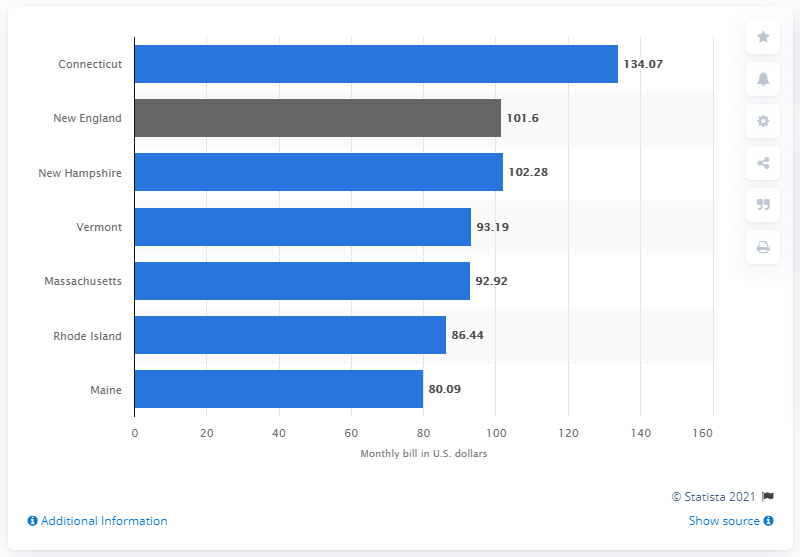List a handful of essential elements in this visual. In 2011, the average residential electricity bill in New Hampshire was $102.28. 